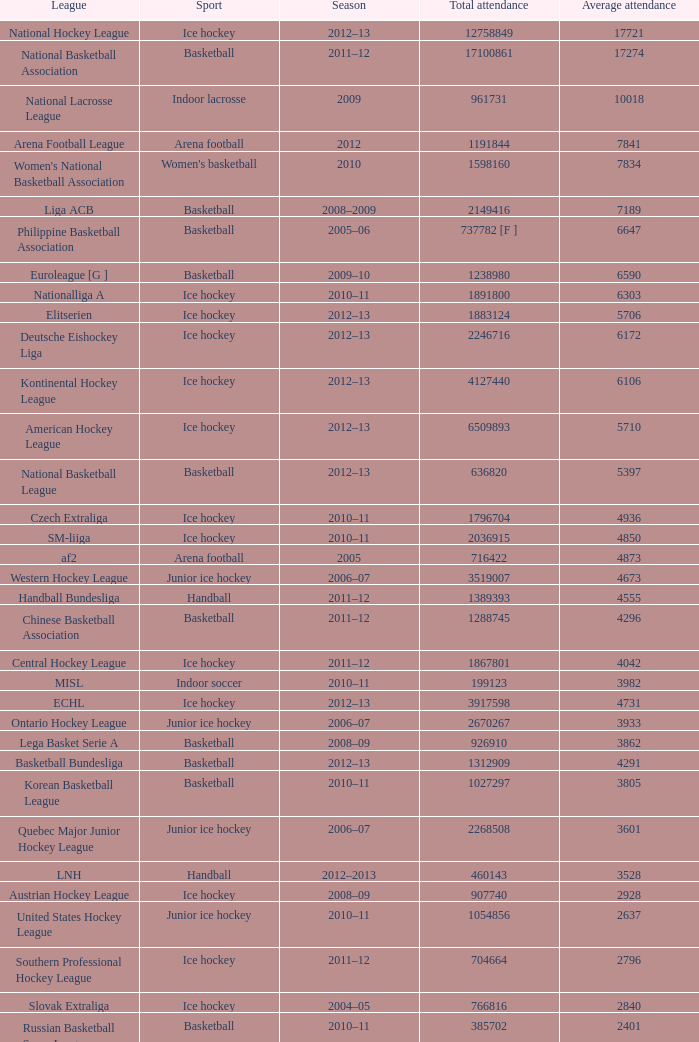What's the mean attendance of the league with a total attendance of 2268508? 3601.0. 